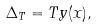<formula> <loc_0><loc_0><loc_500><loc_500>\Delta _ { T } = T y ( x ) ,</formula> 